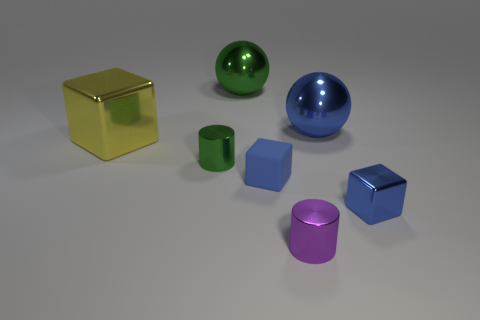Does the purple shiny object have the same size as the green cylinder?
Your response must be concise. Yes. What number of things are small blue things on the right side of the blue sphere or metal objects that are in front of the big green metal object?
Offer a terse response. 5. There is a cylinder right of the green metallic object in front of the large yellow metal block; what is its material?
Offer a terse response. Metal. How many other objects are the same material as the tiny purple object?
Keep it short and to the point. 5. Does the large blue metal object have the same shape as the large green metallic object?
Ensure brevity in your answer.  Yes. What size is the ball that is to the left of the small blue rubber block?
Offer a very short reply. Large. There is a rubber thing; is its size the same as the blue shiny thing that is behind the big yellow thing?
Your answer should be compact. No. Are there fewer small cylinders on the right side of the small green cylinder than purple matte cylinders?
Ensure brevity in your answer.  No. There is another tiny thing that is the same shape as the tiny blue metal object; what is it made of?
Provide a short and direct response. Rubber. What is the shape of the large metallic object that is to the left of the blue shiny sphere and right of the large metallic block?
Offer a terse response. Sphere. 